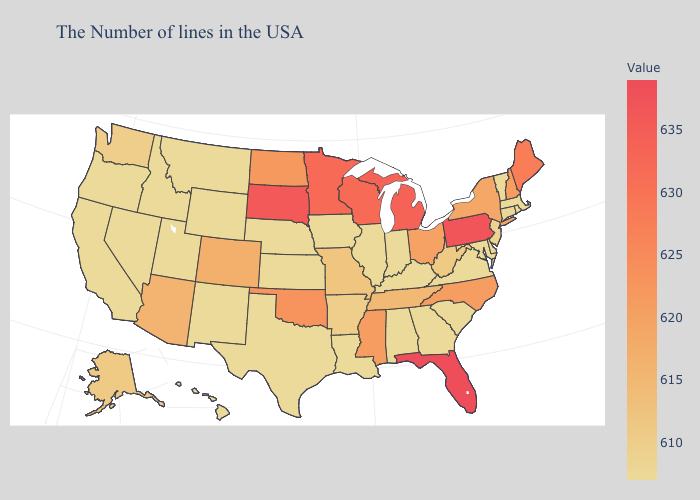Does New York have a lower value than Wisconsin?
Give a very brief answer. Yes. Among the states that border New Mexico , which have the highest value?
Short answer required. Oklahoma. Does South Carolina have the highest value in the USA?
Keep it brief. No. Which states have the lowest value in the MidWest?
Answer briefly. Indiana, Illinois, Iowa, Kansas, Nebraska. Does Pennsylvania have the highest value in the Northeast?
Give a very brief answer. Yes. 